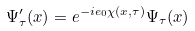Convert formula to latex. <formula><loc_0><loc_0><loc_500><loc_500>\Psi ^ { \prime } _ { \tau } ( x ) = e ^ { - i e _ { 0 } \chi ( x , \tau ) } \Psi _ { \tau } ( x )</formula> 